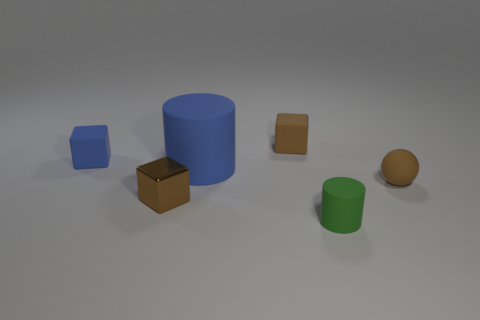If these objects were part of a study, what characteristics might be examined? If this assemblage of objects were part of a study, one might examine characteristics such as the geometry, dimensional ratios, color perception under uniform lighting, material properties reflecting light, and spatial arrangement. 